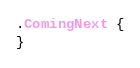Convert code to text. <code><loc_0><loc_0><loc_500><loc_500><_CSS_>.ComingNext {
}
</code> 